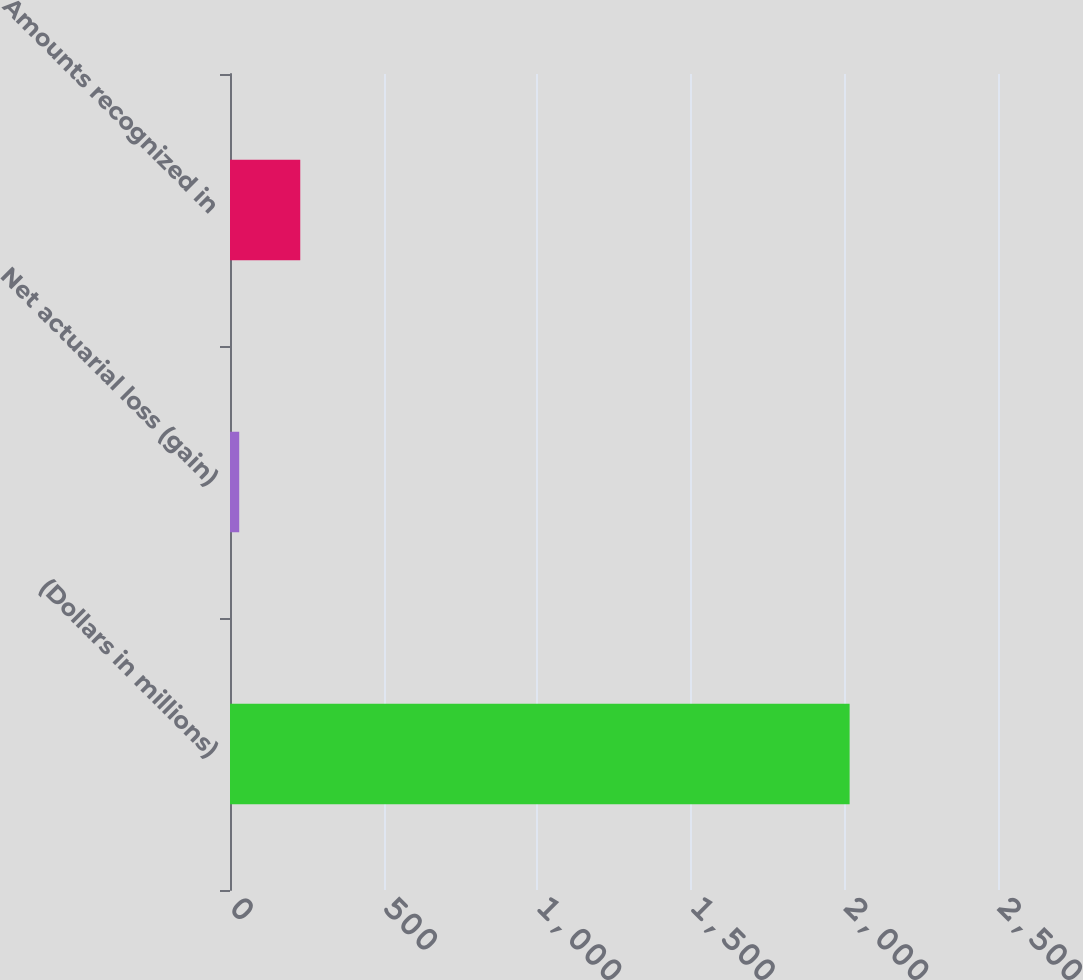Convert chart to OTSL. <chart><loc_0><loc_0><loc_500><loc_500><bar_chart><fcel>(Dollars in millions)<fcel>Net actuarial loss (gain)<fcel>Amounts recognized in<nl><fcel>2017<fcel>30<fcel>228.7<nl></chart> 